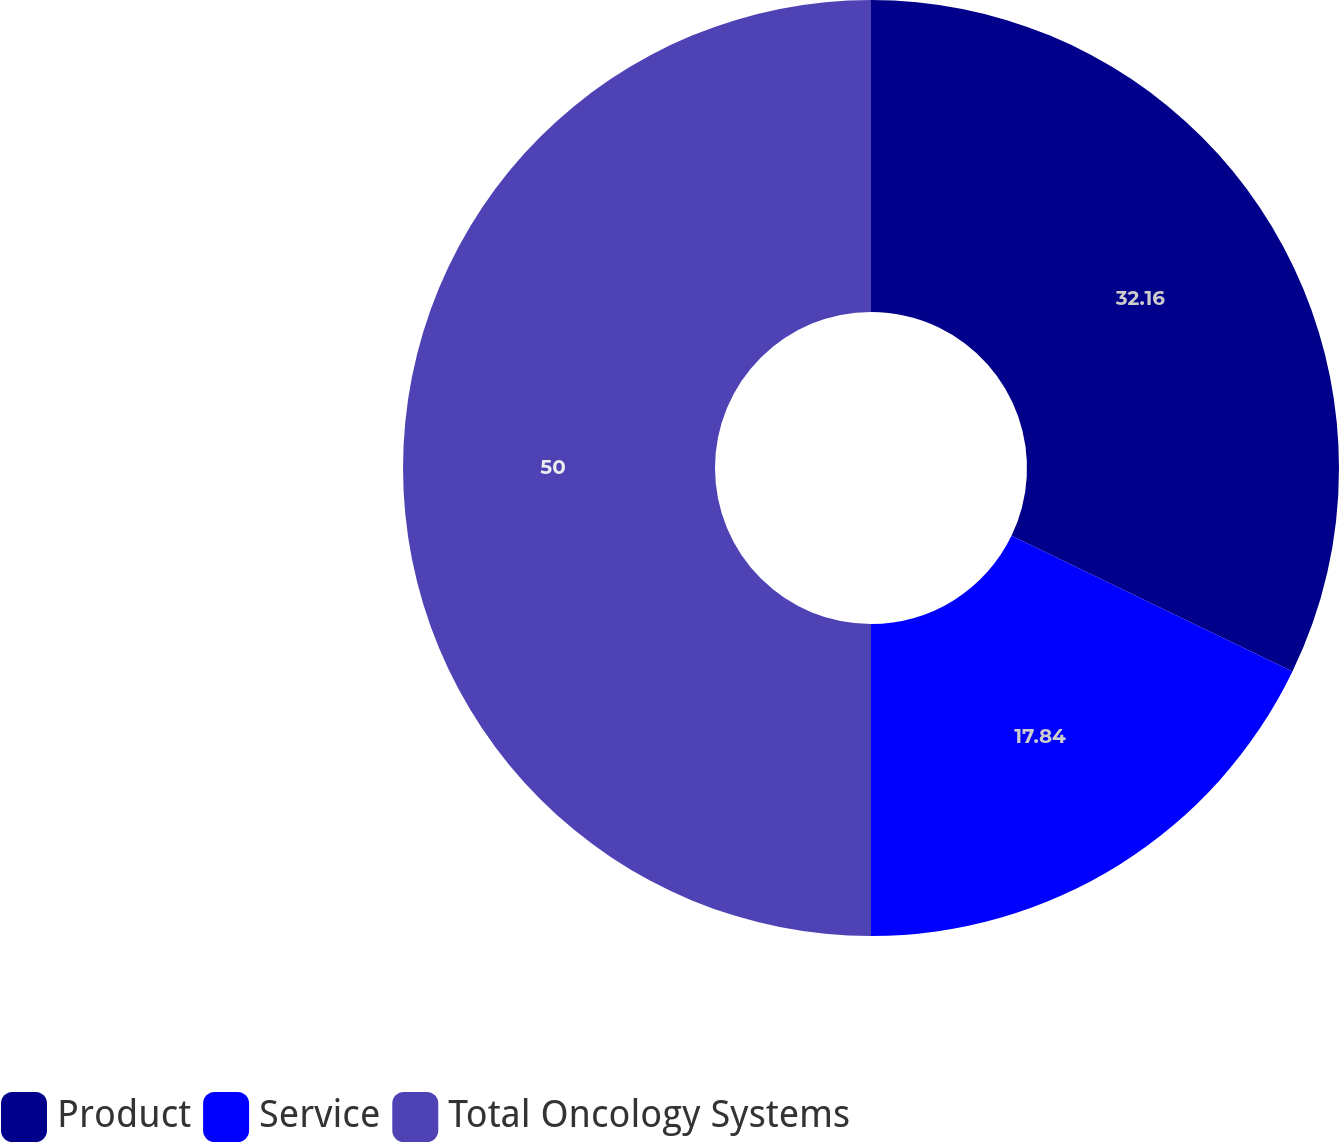Convert chart. <chart><loc_0><loc_0><loc_500><loc_500><pie_chart><fcel>Product<fcel>Service<fcel>Total Oncology Systems<nl><fcel>32.16%<fcel>17.84%<fcel>50.0%<nl></chart> 